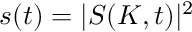<formula> <loc_0><loc_0><loc_500><loc_500>s ( t ) = | S ( K , t ) | ^ { 2 }</formula> 